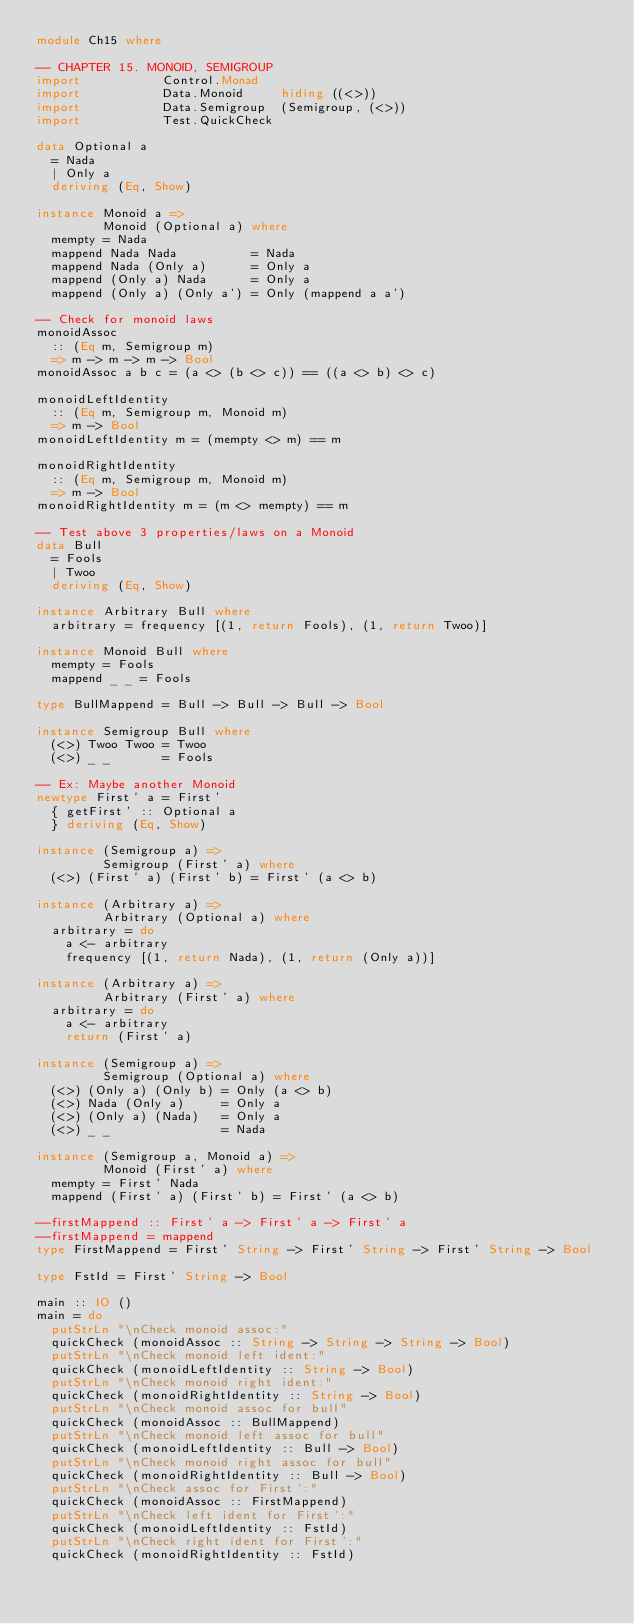<code> <loc_0><loc_0><loc_500><loc_500><_Haskell_>module Ch15 where

-- CHAPTER 15. MONOID, SEMIGROUP
import           Control.Monad
import           Data.Monoid     hiding ((<>))
import           Data.Semigroup  (Semigroup, (<>))
import           Test.QuickCheck

data Optional a
  = Nada
  | Only a
  deriving (Eq, Show)

instance Monoid a =>
         Monoid (Optional a) where
  mempty = Nada
  mappend Nada Nada          = Nada
  mappend Nada (Only a)      = Only a
  mappend (Only a) Nada      = Only a
  mappend (Only a) (Only a') = Only (mappend a a')

-- Check for monoid laws
monoidAssoc
  :: (Eq m, Semigroup m)
  => m -> m -> m -> Bool
monoidAssoc a b c = (a <> (b <> c)) == ((a <> b) <> c)

monoidLeftIdentity
  :: (Eq m, Semigroup m, Monoid m)
  => m -> Bool
monoidLeftIdentity m = (mempty <> m) == m

monoidRightIdentity
  :: (Eq m, Semigroup m, Monoid m)
  => m -> Bool
monoidRightIdentity m = (m <> mempty) == m

-- Test above 3 properties/laws on a Monoid
data Bull
  = Fools
  | Twoo
  deriving (Eq, Show)

instance Arbitrary Bull where
  arbitrary = frequency [(1, return Fools), (1, return Twoo)]

instance Monoid Bull where
  mempty = Fools
  mappend _ _ = Fools

type BullMappend = Bull -> Bull -> Bull -> Bool

instance Semigroup Bull where
  (<>) Twoo Twoo = Twoo
  (<>) _ _       = Fools

-- Ex: Maybe another Monoid
newtype First' a = First'
  { getFirst' :: Optional a
  } deriving (Eq, Show)

instance (Semigroup a) =>
         Semigroup (First' a) where
  (<>) (First' a) (First' b) = First' (a <> b)

instance (Arbitrary a) =>
         Arbitrary (Optional a) where
  arbitrary = do
    a <- arbitrary
    frequency [(1, return Nada), (1, return (Only a))]

instance (Arbitrary a) =>
         Arbitrary (First' a) where
  arbitrary = do
    a <- arbitrary
    return (First' a)

instance (Semigroup a) =>
         Semigroup (Optional a) where
  (<>) (Only a) (Only b) = Only (a <> b)
  (<>) Nada (Only a)     = Only a
  (<>) (Only a) (Nada)   = Only a
  (<>) _ _               = Nada

instance (Semigroup a, Monoid a) =>
         Monoid (First' a) where
  mempty = First' Nada
  mappend (First' a) (First' b) = First' (a <> b)

--firstMappend :: First' a -> First' a -> First' a
--firstMappend = mappend
type FirstMappend = First' String -> First' String -> First' String -> Bool

type FstId = First' String -> Bool

main :: IO ()
main = do
  putStrLn "\nCheck monoid assoc:"
  quickCheck (monoidAssoc :: String -> String -> String -> Bool)
  putStrLn "\nCheck monoid left ident:"
  quickCheck (monoidLeftIdentity :: String -> Bool)
  putStrLn "\nCheck monoid right ident:"
  quickCheck (monoidRightIdentity :: String -> Bool)
  putStrLn "\nCheck monoid assoc for bull"
  quickCheck (monoidAssoc :: BullMappend)
  putStrLn "\nCheck monoid left assoc for bull"
  quickCheck (monoidLeftIdentity :: Bull -> Bool)
  putStrLn "\nCheck monoid right assoc for bull"
  quickCheck (monoidRightIdentity :: Bull -> Bool)
  putStrLn "\nCheck assoc for First':"
  quickCheck (monoidAssoc :: FirstMappend)
  putStrLn "\nCheck left ident for First':"
  quickCheck (monoidLeftIdentity :: FstId)
  putStrLn "\nCheck right ident for First':"
  quickCheck (monoidRightIdentity :: FstId)
</code> 